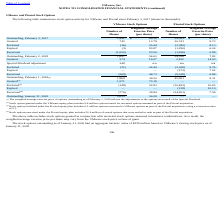According to Vmware's financial document, What were the stock options outstanding value as of January 31, 2020? aggregate intrinsic value of $239 million based on VMware’s closing stock price as of January 31, 2020. The document states: "options outstanding as of January 31, 2020 had an aggregate intrinsic value of $239 million based on VMware’s closing stock price as of January 31, 20..." Also, What was the outstanding number of shares for VMware stock options in 2017? According to the financial document, 1,991 (in thousands). The relevant text states: "Outstanding, February 3, 2017 1,991 $ 69.38 39,361 $ 6.72..." Also, What was the number of granted shares from Pivotal Stock Options in 2018? According to the financial document, 2,832 (in thousands). The relevant text states: "Granted 574 16.07 2,832 14.03..." Also, can you calculate: What was the change in outstanding number of shares for VMware Stock Options between 2017 and 2018? Based on the calculation: 1,647-1,991, the result is -344 (in thousands). This is based on the information: "Outstanding, February 2, 2018 1,647 54.63 54,388 7.82 Outstanding, February 3, 2017 1,991 $ 69.38 39,361 $ 6.72..." The key data points involved are: 1,647, 1,991. Also, How many years did the outstanding Weighted-Average Exercise Price (per share) for VMware stock options exceed $60.00? Based on the analysis, there are 1 instances. The counting process: 2017. Also, can you calculate: What was the percentage change in the outstanding weighted-average exercise price per share for pivotal stock options between 2018 and 2019? To answer this question, I need to perform calculations using the financial data. The calculation is: (8.31-7.82)/7.82, which equals 6.27 (percentage). This is based on the information: "standing, February 1, 2019 (1) 1,969 36.50 45,901 8.31 Outstanding, February 2, 2018 1,647 54.63 54,388 7.82..." The key data points involved are: 7.82, 8.31. 